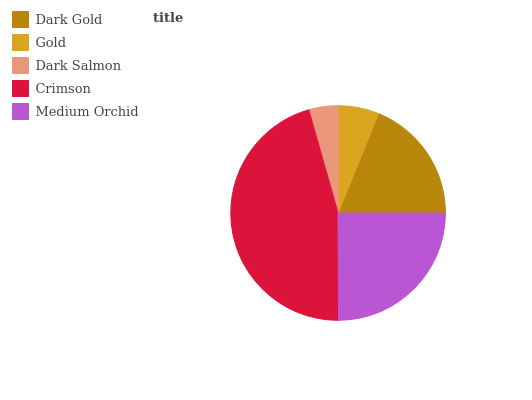Is Dark Salmon the minimum?
Answer yes or no. Yes. Is Crimson the maximum?
Answer yes or no. Yes. Is Gold the minimum?
Answer yes or no. No. Is Gold the maximum?
Answer yes or no. No. Is Dark Gold greater than Gold?
Answer yes or no. Yes. Is Gold less than Dark Gold?
Answer yes or no. Yes. Is Gold greater than Dark Gold?
Answer yes or no. No. Is Dark Gold less than Gold?
Answer yes or no. No. Is Dark Gold the high median?
Answer yes or no. Yes. Is Dark Gold the low median?
Answer yes or no. Yes. Is Crimson the high median?
Answer yes or no. No. Is Medium Orchid the low median?
Answer yes or no. No. 